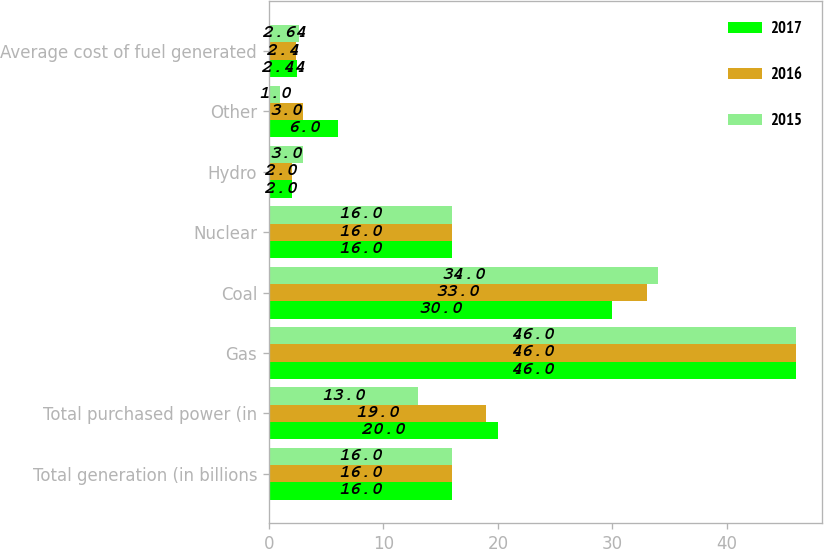Convert chart. <chart><loc_0><loc_0><loc_500><loc_500><stacked_bar_chart><ecel><fcel>Total generation (in billions<fcel>Total purchased power (in<fcel>Gas<fcel>Coal<fcel>Nuclear<fcel>Hydro<fcel>Other<fcel>Average cost of fuel generated<nl><fcel>2017<fcel>16<fcel>20<fcel>46<fcel>30<fcel>16<fcel>2<fcel>6<fcel>2.44<nl><fcel>2016<fcel>16<fcel>19<fcel>46<fcel>33<fcel>16<fcel>2<fcel>3<fcel>2.4<nl><fcel>2015<fcel>16<fcel>13<fcel>46<fcel>34<fcel>16<fcel>3<fcel>1<fcel>2.64<nl></chart> 